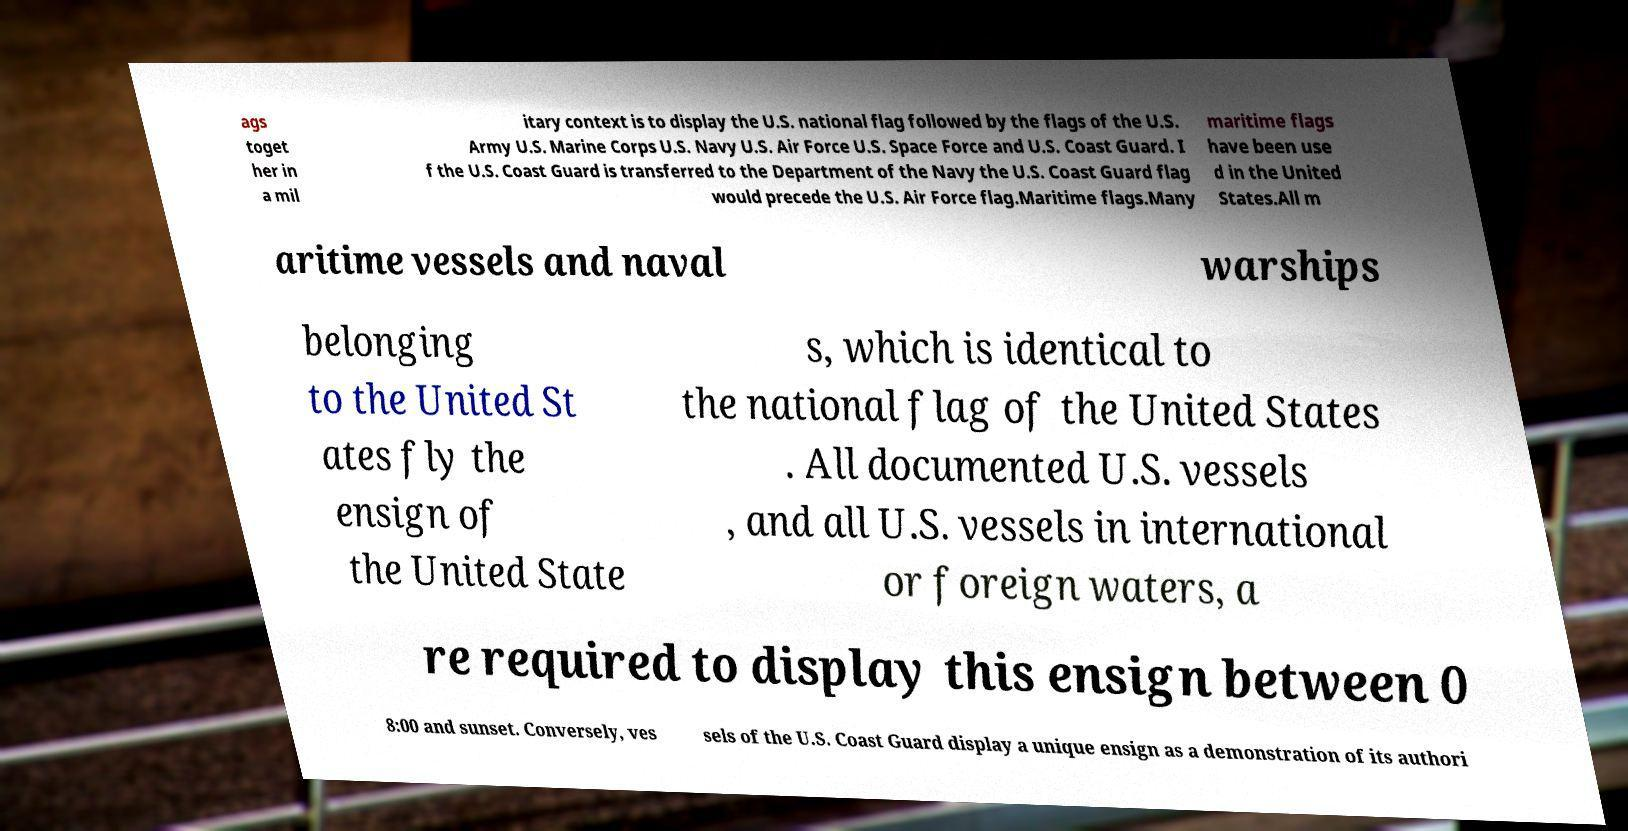Can you accurately transcribe the text from the provided image for me? ags toget her in a mil itary context is to display the U.S. national flag followed by the flags of the U.S. Army U.S. Marine Corps U.S. Navy U.S. Air Force U.S. Space Force and U.S. Coast Guard. I f the U.S. Coast Guard is transferred to the Department of the Navy the U.S. Coast Guard flag would precede the U.S. Air Force flag.Maritime flags.Many maritime flags have been use d in the United States.All m aritime vessels and naval warships belonging to the United St ates fly the ensign of the United State s, which is identical to the national flag of the United States . All documented U.S. vessels , and all U.S. vessels in international or foreign waters, a re required to display this ensign between 0 8:00 and sunset. Conversely, ves sels of the U.S. Coast Guard display a unique ensign as a demonstration of its authori 